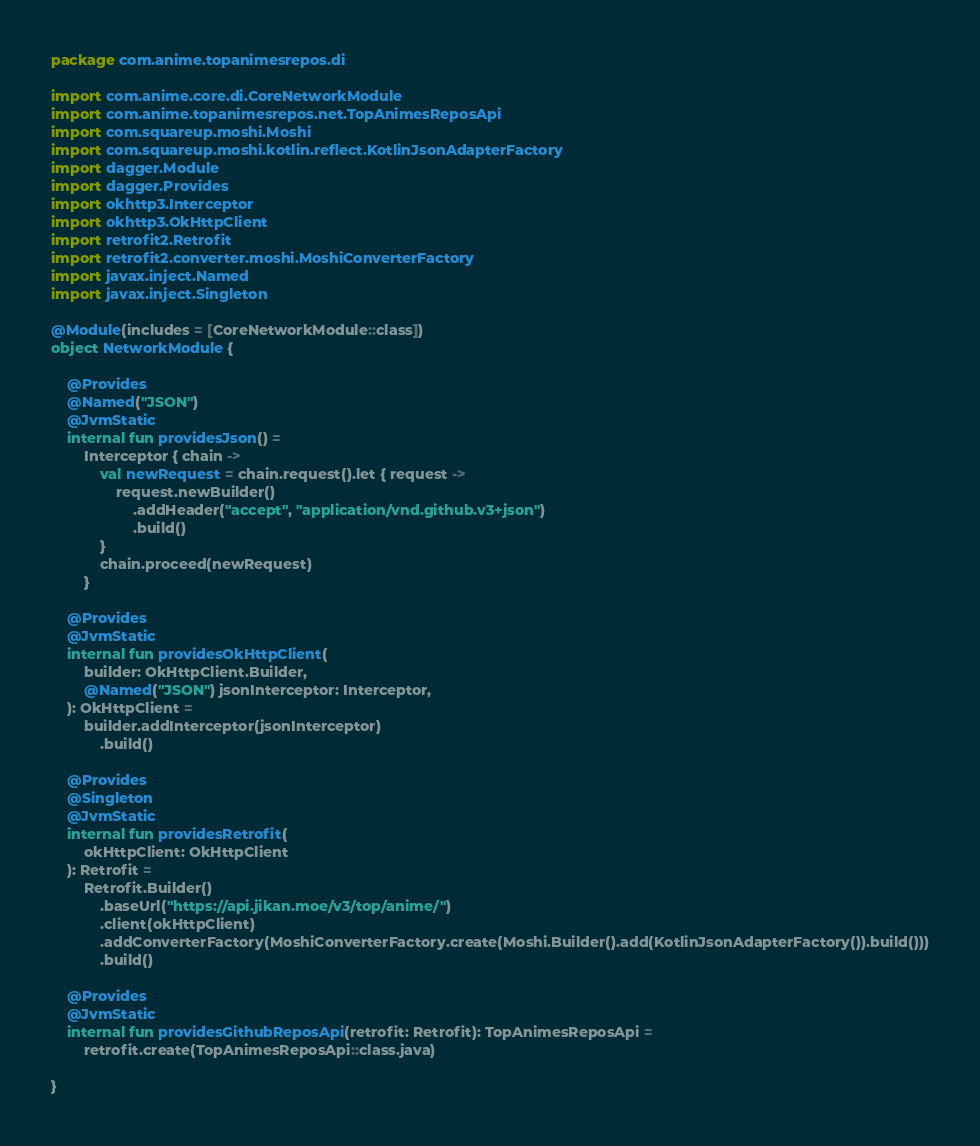<code> <loc_0><loc_0><loc_500><loc_500><_Kotlin_>package com.anime.topanimesrepos.di

import com.anime.core.di.CoreNetworkModule
import com.anime.topanimesrepos.net.TopAnimesReposApi
import com.squareup.moshi.Moshi
import com.squareup.moshi.kotlin.reflect.KotlinJsonAdapterFactory
import dagger.Module
import dagger.Provides
import okhttp3.Interceptor
import okhttp3.OkHttpClient
import retrofit2.Retrofit
import retrofit2.converter.moshi.MoshiConverterFactory
import javax.inject.Named
import javax.inject.Singleton

@Module(includes = [CoreNetworkModule::class])
object NetworkModule {

    @Provides
    @Named("JSON")
    @JvmStatic
    internal fun providesJson() =
        Interceptor { chain ->
            val newRequest = chain.request().let { request ->
                request.newBuilder()
                    .addHeader("accept", "application/vnd.github.v3+json")
                    .build()
            }
            chain.proceed(newRequest)
        }

    @Provides
    @JvmStatic
    internal fun providesOkHttpClient(
        builder: OkHttpClient.Builder,
        @Named("JSON") jsonInterceptor: Interceptor,
    ): OkHttpClient =
        builder.addInterceptor(jsonInterceptor)
            .build()

    @Provides
    @Singleton
    @JvmStatic
    internal fun providesRetrofit(
        okHttpClient: OkHttpClient
    ): Retrofit =
        Retrofit.Builder()
            .baseUrl("https://api.jikan.moe/v3/top/anime/")
            .client(okHttpClient)
            .addConverterFactory(MoshiConverterFactory.create(Moshi.Builder().add(KotlinJsonAdapterFactory()).build()))
            .build()

    @Provides
    @JvmStatic
    internal fun providesGithubReposApi(retrofit: Retrofit): TopAnimesReposApi =
        retrofit.create(TopAnimesReposApi::class.java)

}
</code> 